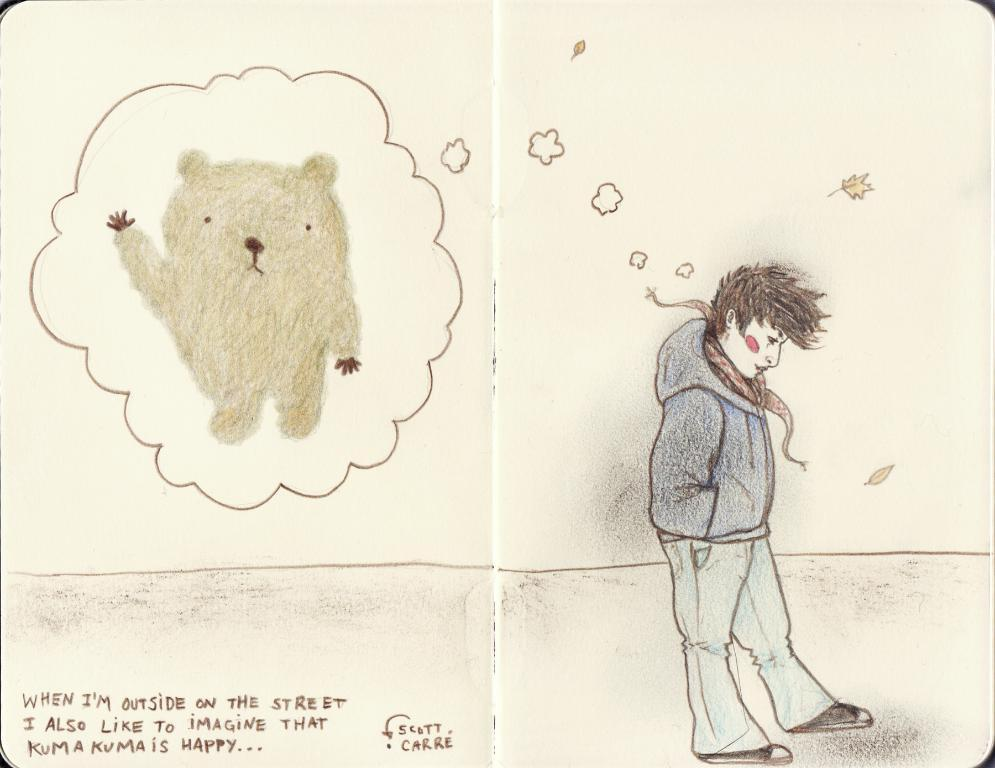What is the main subject of the painting? There is a boy in the painting. What is the boy doing in the painting? The boy is standing in the painting. What is the boy wearing in the painting? The boy is wearing a blue jacket in the painting. What is the boy dreaming about in the painting? The boy is dreaming of a toy in the painting. What can be found in the bottom left of the image? There is text written in the bottom left of the image. Can you tell me what type of doctor is standing next to the boy in the painting? There is no doctor present in the painting; it only features a boy. What scale is used to measure the size of the toy the boy is dreaming about? There is no scale present in the painting, and the size of the toy is not specified. 